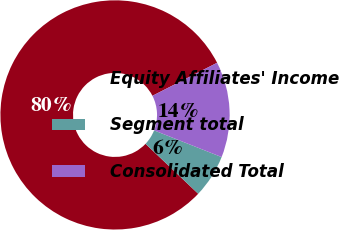Convert chart. <chart><loc_0><loc_0><loc_500><loc_500><pie_chart><fcel>Equity Affiliates' Income<fcel>Segment total<fcel>Consolidated Total<nl><fcel>80.41%<fcel>6.08%<fcel>13.51%<nl></chart> 